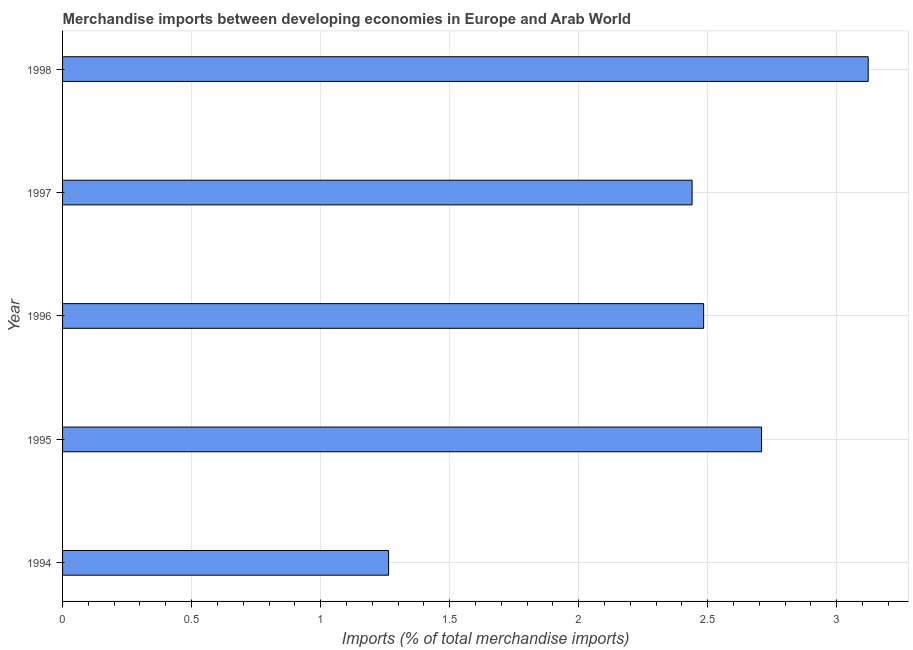Does the graph contain any zero values?
Offer a very short reply. No. What is the title of the graph?
Ensure brevity in your answer.  Merchandise imports between developing economies in Europe and Arab World. What is the label or title of the X-axis?
Provide a succinct answer. Imports (% of total merchandise imports). What is the label or title of the Y-axis?
Offer a very short reply. Year. What is the merchandise imports in 1995?
Your answer should be very brief. 2.71. Across all years, what is the maximum merchandise imports?
Give a very brief answer. 3.12. Across all years, what is the minimum merchandise imports?
Your answer should be very brief. 1.26. In which year was the merchandise imports minimum?
Your answer should be very brief. 1994. What is the sum of the merchandise imports?
Offer a very short reply. 12.02. What is the difference between the merchandise imports in 1994 and 1997?
Ensure brevity in your answer.  -1.18. What is the average merchandise imports per year?
Your answer should be very brief. 2.4. What is the median merchandise imports?
Your answer should be very brief. 2.48. In how many years, is the merchandise imports greater than 1 %?
Provide a succinct answer. 5. Do a majority of the years between 1994 and 1996 (inclusive) have merchandise imports greater than 0.2 %?
Give a very brief answer. Yes. What is the ratio of the merchandise imports in 1994 to that in 1998?
Your answer should be compact. 0.41. Is the difference between the merchandise imports in 1995 and 1996 greater than the difference between any two years?
Your answer should be compact. No. What is the difference between the highest and the second highest merchandise imports?
Ensure brevity in your answer.  0.41. Is the sum of the merchandise imports in 1994 and 1998 greater than the maximum merchandise imports across all years?
Keep it short and to the point. Yes. What is the difference between the highest and the lowest merchandise imports?
Your response must be concise. 1.86. How many years are there in the graph?
Make the answer very short. 5. What is the difference between two consecutive major ticks on the X-axis?
Your response must be concise. 0.5. What is the Imports (% of total merchandise imports) of 1994?
Keep it short and to the point. 1.26. What is the Imports (% of total merchandise imports) of 1995?
Your answer should be very brief. 2.71. What is the Imports (% of total merchandise imports) in 1996?
Ensure brevity in your answer.  2.48. What is the Imports (% of total merchandise imports) of 1997?
Ensure brevity in your answer.  2.44. What is the Imports (% of total merchandise imports) in 1998?
Provide a short and direct response. 3.12. What is the difference between the Imports (% of total merchandise imports) in 1994 and 1995?
Your answer should be compact. -1.45. What is the difference between the Imports (% of total merchandise imports) in 1994 and 1996?
Provide a succinct answer. -1.22. What is the difference between the Imports (% of total merchandise imports) in 1994 and 1997?
Give a very brief answer. -1.18. What is the difference between the Imports (% of total merchandise imports) in 1994 and 1998?
Provide a succinct answer. -1.86. What is the difference between the Imports (% of total merchandise imports) in 1995 and 1996?
Give a very brief answer. 0.22. What is the difference between the Imports (% of total merchandise imports) in 1995 and 1997?
Your response must be concise. 0.27. What is the difference between the Imports (% of total merchandise imports) in 1995 and 1998?
Give a very brief answer. -0.41. What is the difference between the Imports (% of total merchandise imports) in 1996 and 1997?
Ensure brevity in your answer.  0.04. What is the difference between the Imports (% of total merchandise imports) in 1996 and 1998?
Ensure brevity in your answer.  -0.64. What is the difference between the Imports (% of total merchandise imports) in 1997 and 1998?
Offer a very short reply. -0.68. What is the ratio of the Imports (% of total merchandise imports) in 1994 to that in 1995?
Give a very brief answer. 0.47. What is the ratio of the Imports (% of total merchandise imports) in 1994 to that in 1996?
Provide a succinct answer. 0.51. What is the ratio of the Imports (% of total merchandise imports) in 1994 to that in 1997?
Your answer should be very brief. 0.52. What is the ratio of the Imports (% of total merchandise imports) in 1994 to that in 1998?
Keep it short and to the point. 0.41. What is the ratio of the Imports (% of total merchandise imports) in 1995 to that in 1996?
Give a very brief answer. 1.09. What is the ratio of the Imports (% of total merchandise imports) in 1995 to that in 1997?
Keep it short and to the point. 1.11. What is the ratio of the Imports (% of total merchandise imports) in 1995 to that in 1998?
Offer a terse response. 0.87. What is the ratio of the Imports (% of total merchandise imports) in 1996 to that in 1997?
Offer a terse response. 1.02. What is the ratio of the Imports (% of total merchandise imports) in 1996 to that in 1998?
Your answer should be compact. 0.8. What is the ratio of the Imports (% of total merchandise imports) in 1997 to that in 1998?
Keep it short and to the point. 0.78. 